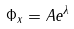Convert formula to latex. <formula><loc_0><loc_0><loc_500><loc_500>\Phi _ { x } = A e ^ { \lambda }</formula> 